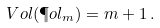Convert formula to latex. <formula><loc_0><loc_0><loc_500><loc_500>\ V o l ( \P o l _ { m } ) = m + 1 \, .</formula> 